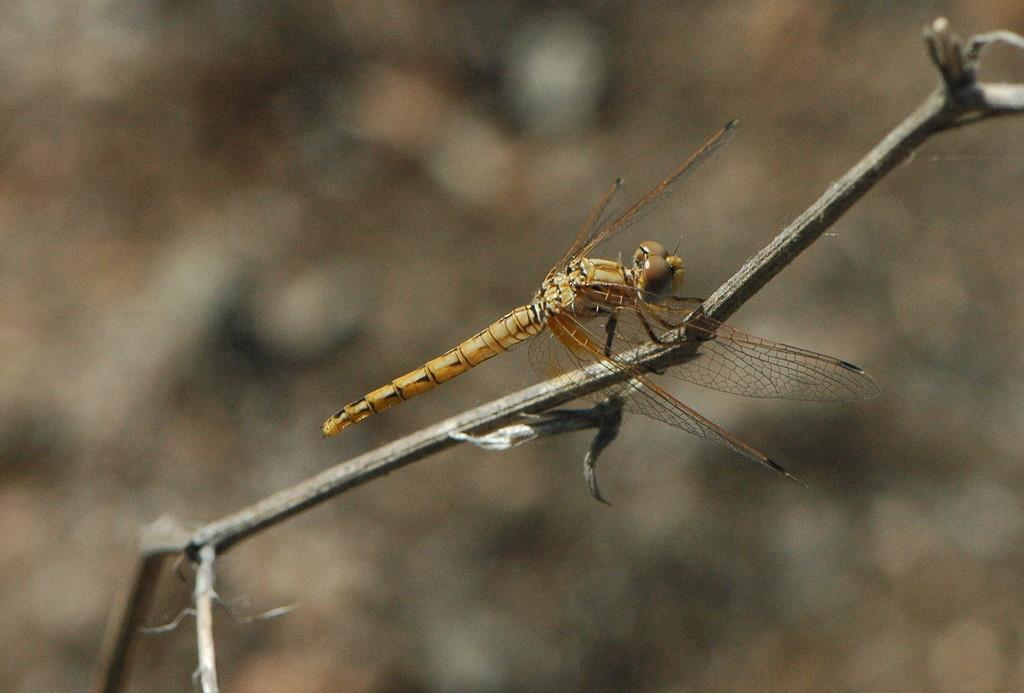What is present on the stem in the image? There is a fly on a stem in the image. Can you describe the background of the image? The background of the image is blurry. What type of brass instrument is being played in the image? There is no brass instrument present in the image; it features a fly on a stem with a blurry background. What type of business is being conducted in the image? There is no business activity present in the image; it features a fly on a stem with a blurry background. 